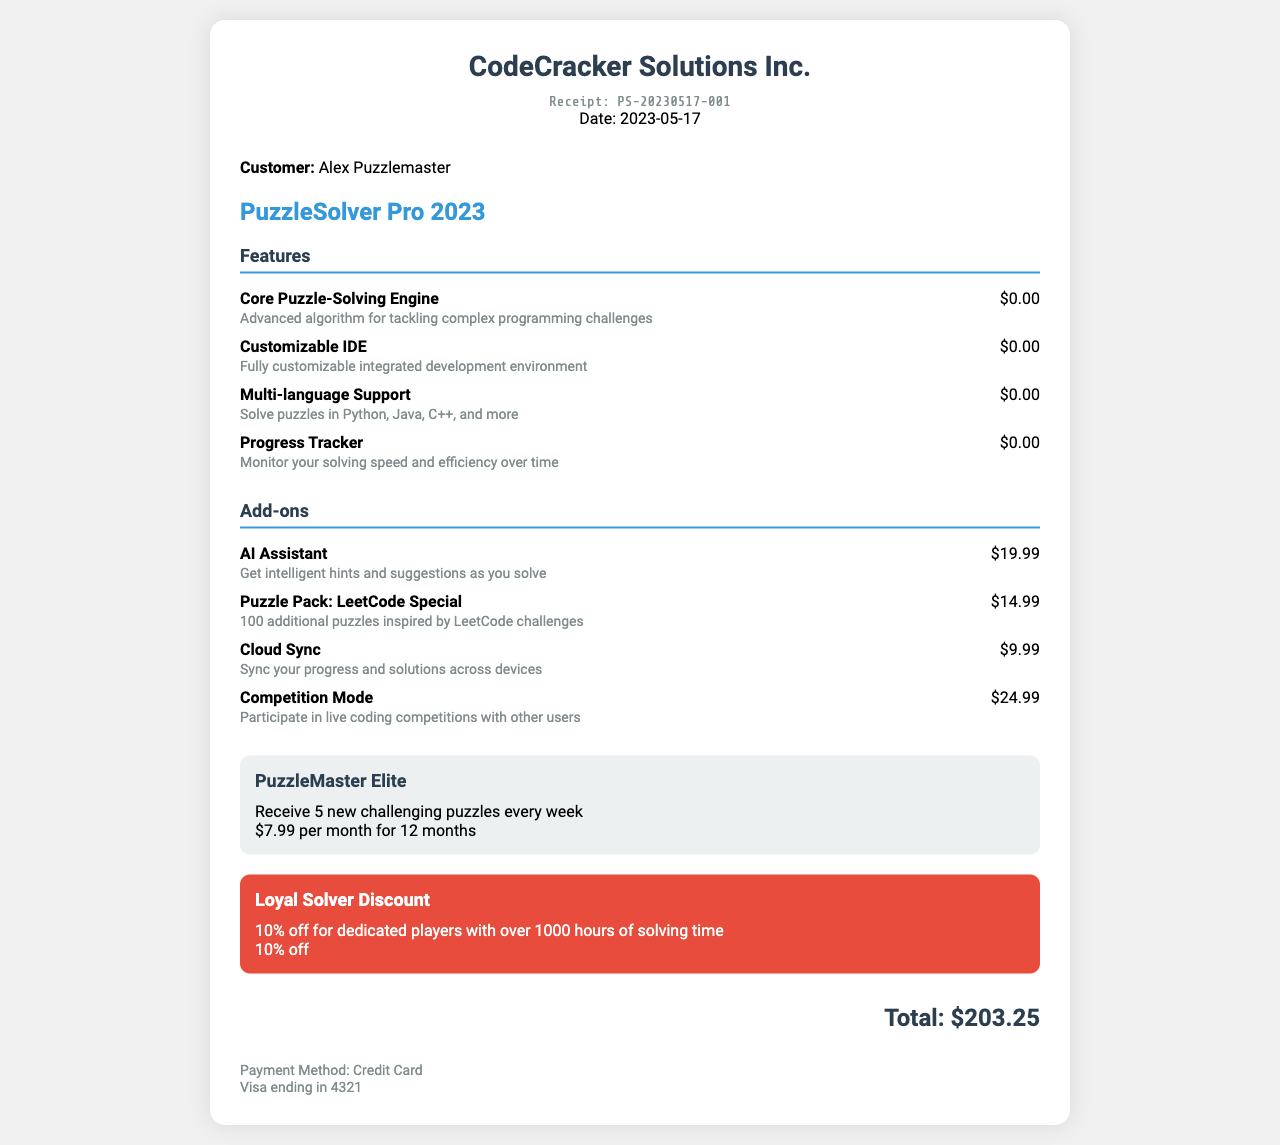What is the company name? The company name is listed at the top of the document as the provider of the software.
Answer: CodeCracker Solutions Inc What is the receipt number? The receipt number is a unique identifier for this transaction, found prominently on the document.
Answer: PS-20230517-001 How much does the AI Assistant add-on cost? The price for the AI Assistant is specified under the add-ons section of the document.
Answer: $19.99 What is the total price after discount? The total price is calculated by summing the base price, add-ons, subscription cost, and applying the discount.
Answer: $84.68 How many months is the subscription for? The subscription length is specified in months within the subscription section of the document.
Answer: 12 months What is the description of the Competition Mode add-on? The description is provided next to the name in the add-ons section to explain what it offers.
Answer: Participate in live coding competitions with other users What percentage is the discount given? The discount percentage can be found in the discount section of the document.
Answer: 10% Who is the customer? The customer's name is indicated following the customer information section.
Answer: Alex Puzzlemaster What feature aids in tracking performance over time? This feature is mentioned in the features section of the receipt to describe its functionality.
Answer: Progress Tracker 